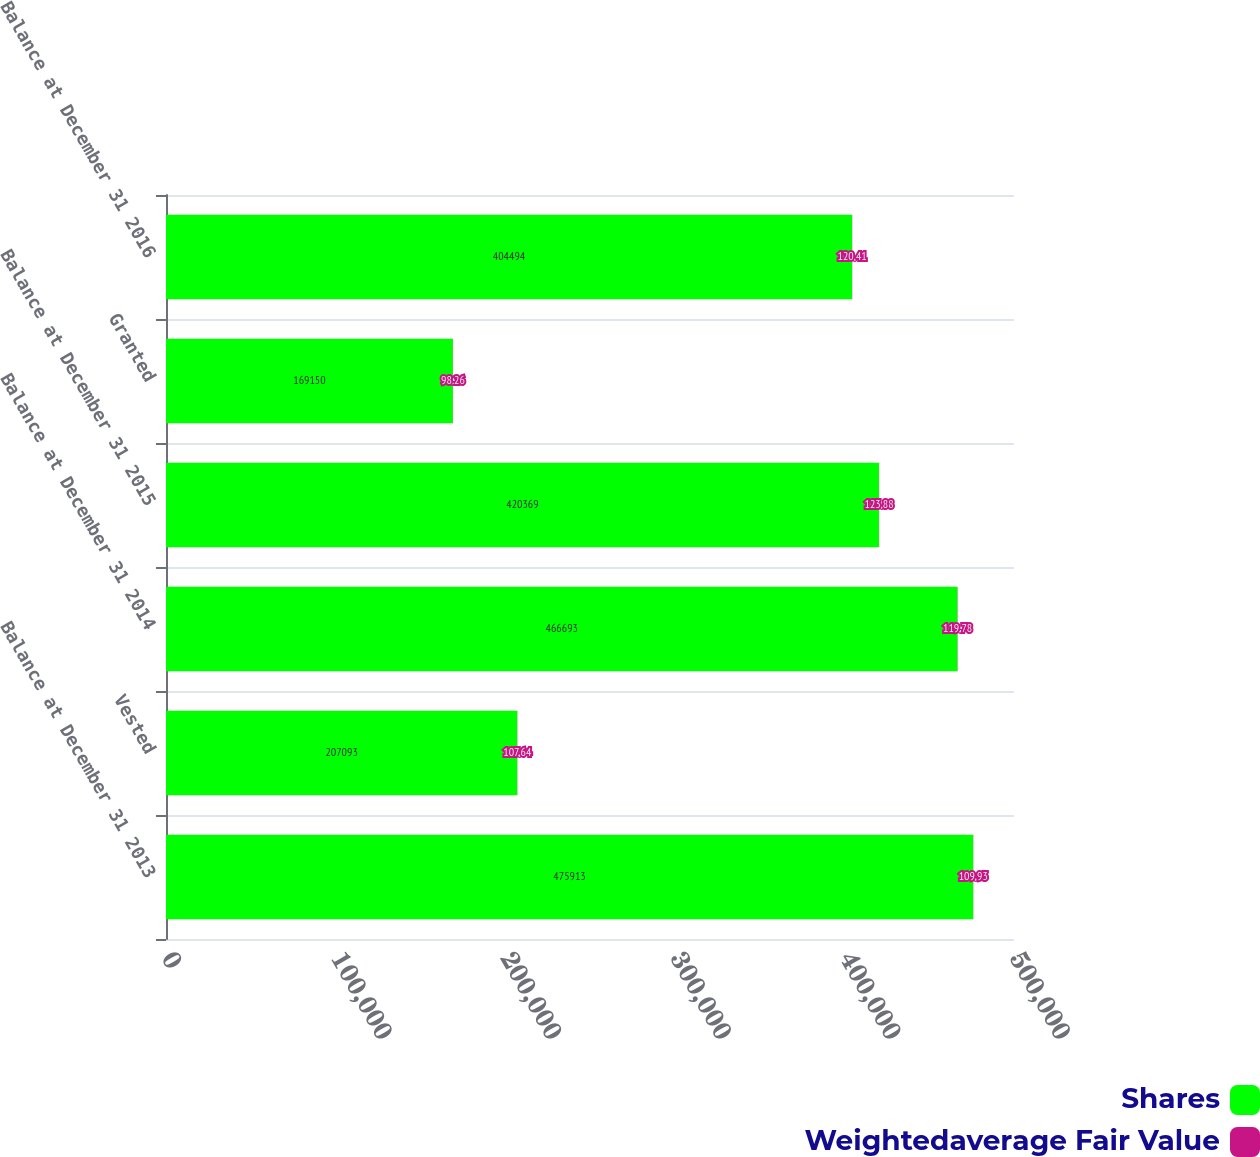Convert chart. <chart><loc_0><loc_0><loc_500><loc_500><stacked_bar_chart><ecel><fcel>Balance at December 31 2013<fcel>Vested<fcel>Balance at December 31 2014<fcel>Balance at December 31 2015<fcel>Granted<fcel>Balance at December 31 2016<nl><fcel>Shares<fcel>475913<fcel>207093<fcel>466693<fcel>420369<fcel>169150<fcel>404494<nl><fcel>Weightedaverage Fair Value<fcel>109.93<fcel>107.64<fcel>119.78<fcel>123.88<fcel>98.26<fcel>120.41<nl></chart> 